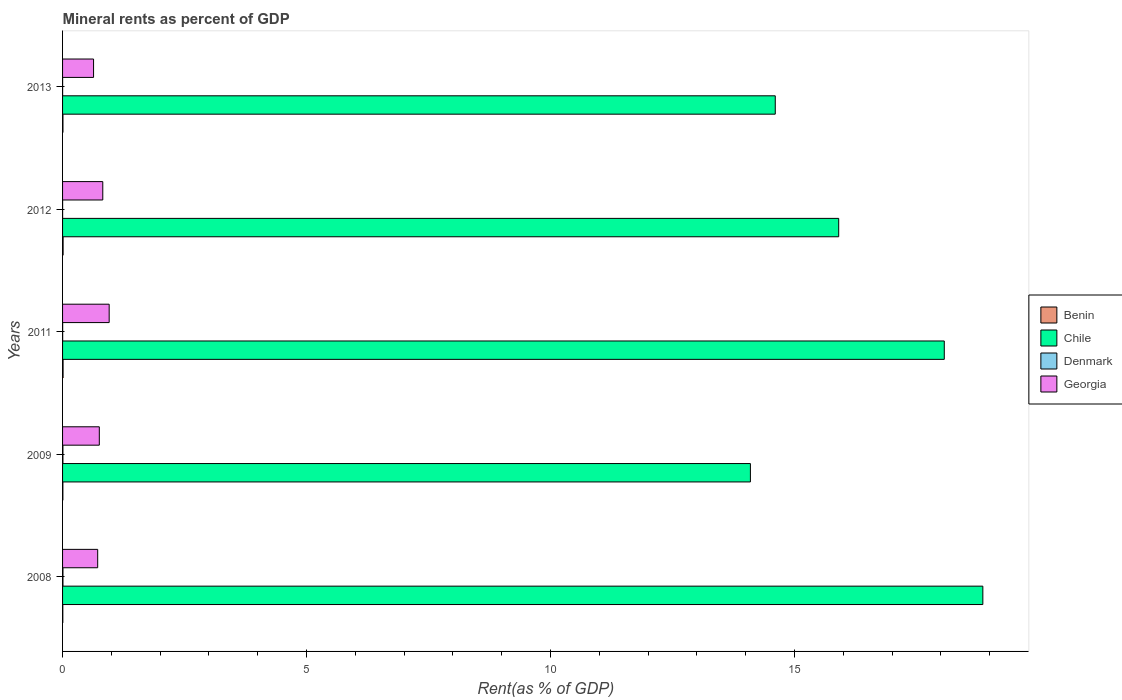How many bars are there on the 5th tick from the top?
Your answer should be compact. 4. How many bars are there on the 5th tick from the bottom?
Provide a short and direct response. 4. What is the label of the 1st group of bars from the top?
Provide a succinct answer. 2013. In how many cases, is the number of bars for a given year not equal to the number of legend labels?
Offer a terse response. 0. What is the mineral rent in Georgia in 2011?
Give a very brief answer. 0.96. Across all years, what is the maximum mineral rent in Chile?
Your answer should be compact. 18.86. Across all years, what is the minimum mineral rent in Georgia?
Give a very brief answer. 0.64. In which year was the mineral rent in Benin minimum?
Provide a short and direct response. 2008. What is the total mineral rent in Georgia in the graph?
Offer a terse response. 3.89. What is the difference between the mineral rent in Georgia in 2011 and that in 2012?
Ensure brevity in your answer.  0.13. What is the difference between the mineral rent in Denmark in 2008 and the mineral rent in Georgia in 2012?
Offer a terse response. -0.82. What is the average mineral rent in Chile per year?
Ensure brevity in your answer.  16.31. In the year 2009, what is the difference between the mineral rent in Georgia and mineral rent in Benin?
Keep it short and to the point. 0.75. In how many years, is the mineral rent in Chile greater than 8 %?
Your response must be concise. 5. What is the ratio of the mineral rent in Benin in 2008 to that in 2013?
Offer a terse response. 0.62. Is the difference between the mineral rent in Georgia in 2011 and 2012 greater than the difference between the mineral rent in Benin in 2011 and 2012?
Ensure brevity in your answer.  Yes. What is the difference between the highest and the second highest mineral rent in Georgia?
Keep it short and to the point. 0.13. What is the difference between the highest and the lowest mineral rent in Georgia?
Your answer should be compact. 0.32. Is the sum of the mineral rent in Benin in 2009 and 2012 greater than the maximum mineral rent in Denmark across all years?
Provide a short and direct response. Yes. What does the 4th bar from the top in 2012 represents?
Provide a succinct answer. Benin. What does the 3rd bar from the bottom in 2011 represents?
Provide a succinct answer. Denmark. Are all the bars in the graph horizontal?
Offer a terse response. Yes. What is the difference between two consecutive major ticks on the X-axis?
Offer a terse response. 5. Are the values on the major ticks of X-axis written in scientific E-notation?
Offer a terse response. No. Does the graph contain any zero values?
Give a very brief answer. No. Does the graph contain grids?
Ensure brevity in your answer.  No. Where does the legend appear in the graph?
Keep it short and to the point. Center right. How are the legend labels stacked?
Offer a terse response. Vertical. What is the title of the graph?
Offer a very short reply. Mineral rents as percent of GDP. What is the label or title of the X-axis?
Give a very brief answer. Rent(as % of GDP). What is the Rent(as % of GDP) of Benin in 2008?
Your answer should be very brief. 0. What is the Rent(as % of GDP) in Chile in 2008?
Make the answer very short. 18.86. What is the Rent(as % of GDP) in Denmark in 2008?
Give a very brief answer. 0.01. What is the Rent(as % of GDP) in Georgia in 2008?
Give a very brief answer. 0.72. What is the Rent(as % of GDP) of Benin in 2009?
Offer a terse response. 0.01. What is the Rent(as % of GDP) of Chile in 2009?
Provide a short and direct response. 14.1. What is the Rent(as % of GDP) in Denmark in 2009?
Give a very brief answer. 0.01. What is the Rent(as % of GDP) in Georgia in 2009?
Keep it short and to the point. 0.75. What is the Rent(as % of GDP) of Benin in 2011?
Your response must be concise. 0.01. What is the Rent(as % of GDP) in Chile in 2011?
Offer a terse response. 18.07. What is the Rent(as % of GDP) of Denmark in 2011?
Provide a short and direct response. 0. What is the Rent(as % of GDP) in Georgia in 2011?
Your response must be concise. 0.96. What is the Rent(as % of GDP) of Benin in 2012?
Ensure brevity in your answer.  0.01. What is the Rent(as % of GDP) in Chile in 2012?
Provide a succinct answer. 15.91. What is the Rent(as % of GDP) of Denmark in 2012?
Give a very brief answer. 0. What is the Rent(as % of GDP) of Georgia in 2012?
Offer a terse response. 0.82. What is the Rent(as % of GDP) in Benin in 2013?
Offer a very short reply. 0.01. What is the Rent(as % of GDP) in Chile in 2013?
Your response must be concise. 14.61. What is the Rent(as % of GDP) of Denmark in 2013?
Provide a short and direct response. 0. What is the Rent(as % of GDP) in Georgia in 2013?
Ensure brevity in your answer.  0.64. Across all years, what is the maximum Rent(as % of GDP) in Benin?
Your answer should be very brief. 0.01. Across all years, what is the maximum Rent(as % of GDP) in Chile?
Make the answer very short. 18.86. Across all years, what is the maximum Rent(as % of GDP) in Denmark?
Offer a very short reply. 0.01. Across all years, what is the maximum Rent(as % of GDP) in Georgia?
Your answer should be compact. 0.96. Across all years, what is the minimum Rent(as % of GDP) in Benin?
Provide a succinct answer. 0. Across all years, what is the minimum Rent(as % of GDP) in Chile?
Provide a short and direct response. 14.1. Across all years, what is the minimum Rent(as % of GDP) of Denmark?
Your answer should be very brief. 0. Across all years, what is the minimum Rent(as % of GDP) of Georgia?
Keep it short and to the point. 0.64. What is the total Rent(as % of GDP) of Benin in the graph?
Offer a terse response. 0.04. What is the total Rent(as % of GDP) of Chile in the graph?
Make the answer very short. 81.54. What is the total Rent(as % of GDP) in Denmark in the graph?
Offer a terse response. 0.02. What is the total Rent(as % of GDP) in Georgia in the graph?
Your response must be concise. 3.89. What is the difference between the Rent(as % of GDP) of Benin in 2008 and that in 2009?
Your response must be concise. -0. What is the difference between the Rent(as % of GDP) of Chile in 2008 and that in 2009?
Offer a terse response. 4.76. What is the difference between the Rent(as % of GDP) of Denmark in 2008 and that in 2009?
Offer a terse response. 0. What is the difference between the Rent(as % of GDP) of Georgia in 2008 and that in 2009?
Your answer should be very brief. -0.03. What is the difference between the Rent(as % of GDP) in Benin in 2008 and that in 2011?
Keep it short and to the point. -0.01. What is the difference between the Rent(as % of GDP) in Chile in 2008 and that in 2011?
Keep it short and to the point. 0.79. What is the difference between the Rent(as % of GDP) of Denmark in 2008 and that in 2011?
Provide a short and direct response. 0.01. What is the difference between the Rent(as % of GDP) of Georgia in 2008 and that in 2011?
Ensure brevity in your answer.  -0.24. What is the difference between the Rent(as % of GDP) of Benin in 2008 and that in 2012?
Ensure brevity in your answer.  -0.01. What is the difference between the Rent(as % of GDP) of Chile in 2008 and that in 2012?
Your answer should be compact. 2.95. What is the difference between the Rent(as % of GDP) in Denmark in 2008 and that in 2012?
Make the answer very short. 0.01. What is the difference between the Rent(as % of GDP) in Georgia in 2008 and that in 2012?
Ensure brevity in your answer.  -0.1. What is the difference between the Rent(as % of GDP) in Benin in 2008 and that in 2013?
Make the answer very short. -0. What is the difference between the Rent(as % of GDP) in Chile in 2008 and that in 2013?
Provide a short and direct response. 4.25. What is the difference between the Rent(as % of GDP) of Denmark in 2008 and that in 2013?
Make the answer very short. 0.01. What is the difference between the Rent(as % of GDP) in Georgia in 2008 and that in 2013?
Make the answer very short. 0.08. What is the difference between the Rent(as % of GDP) in Benin in 2009 and that in 2011?
Keep it short and to the point. -0. What is the difference between the Rent(as % of GDP) in Chile in 2009 and that in 2011?
Give a very brief answer. -3.97. What is the difference between the Rent(as % of GDP) in Denmark in 2009 and that in 2011?
Ensure brevity in your answer.  0.01. What is the difference between the Rent(as % of GDP) of Georgia in 2009 and that in 2011?
Make the answer very short. -0.2. What is the difference between the Rent(as % of GDP) of Benin in 2009 and that in 2012?
Give a very brief answer. -0. What is the difference between the Rent(as % of GDP) of Chile in 2009 and that in 2012?
Give a very brief answer. -1.81. What is the difference between the Rent(as % of GDP) of Denmark in 2009 and that in 2012?
Ensure brevity in your answer.  0.01. What is the difference between the Rent(as % of GDP) of Georgia in 2009 and that in 2012?
Provide a short and direct response. -0.07. What is the difference between the Rent(as % of GDP) in Benin in 2009 and that in 2013?
Offer a very short reply. -0. What is the difference between the Rent(as % of GDP) in Chile in 2009 and that in 2013?
Your answer should be very brief. -0.51. What is the difference between the Rent(as % of GDP) of Denmark in 2009 and that in 2013?
Provide a short and direct response. 0.01. What is the difference between the Rent(as % of GDP) of Georgia in 2009 and that in 2013?
Your response must be concise. 0.12. What is the difference between the Rent(as % of GDP) in Benin in 2011 and that in 2012?
Give a very brief answer. -0. What is the difference between the Rent(as % of GDP) in Chile in 2011 and that in 2012?
Your answer should be compact. 2.16. What is the difference between the Rent(as % of GDP) in Denmark in 2011 and that in 2012?
Make the answer very short. 0. What is the difference between the Rent(as % of GDP) of Georgia in 2011 and that in 2012?
Keep it short and to the point. 0.13. What is the difference between the Rent(as % of GDP) in Benin in 2011 and that in 2013?
Keep it short and to the point. 0. What is the difference between the Rent(as % of GDP) in Chile in 2011 and that in 2013?
Give a very brief answer. 3.46. What is the difference between the Rent(as % of GDP) in Denmark in 2011 and that in 2013?
Offer a very short reply. 0. What is the difference between the Rent(as % of GDP) in Georgia in 2011 and that in 2013?
Your response must be concise. 0.32. What is the difference between the Rent(as % of GDP) in Benin in 2012 and that in 2013?
Offer a very short reply. 0. What is the difference between the Rent(as % of GDP) of Denmark in 2012 and that in 2013?
Your answer should be compact. 0. What is the difference between the Rent(as % of GDP) in Georgia in 2012 and that in 2013?
Provide a short and direct response. 0.19. What is the difference between the Rent(as % of GDP) of Benin in 2008 and the Rent(as % of GDP) of Chile in 2009?
Keep it short and to the point. -14.09. What is the difference between the Rent(as % of GDP) in Benin in 2008 and the Rent(as % of GDP) in Denmark in 2009?
Offer a very short reply. -0. What is the difference between the Rent(as % of GDP) in Benin in 2008 and the Rent(as % of GDP) in Georgia in 2009?
Make the answer very short. -0.75. What is the difference between the Rent(as % of GDP) in Chile in 2008 and the Rent(as % of GDP) in Denmark in 2009?
Give a very brief answer. 18.85. What is the difference between the Rent(as % of GDP) in Chile in 2008 and the Rent(as % of GDP) in Georgia in 2009?
Your answer should be compact. 18.11. What is the difference between the Rent(as % of GDP) in Denmark in 2008 and the Rent(as % of GDP) in Georgia in 2009?
Your answer should be very brief. -0.75. What is the difference between the Rent(as % of GDP) of Benin in 2008 and the Rent(as % of GDP) of Chile in 2011?
Offer a very short reply. -18.06. What is the difference between the Rent(as % of GDP) in Benin in 2008 and the Rent(as % of GDP) in Denmark in 2011?
Offer a terse response. 0. What is the difference between the Rent(as % of GDP) of Benin in 2008 and the Rent(as % of GDP) of Georgia in 2011?
Provide a short and direct response. -0.95. What is the difference between the Rent(as % of GDP) of Chile in 2008 and the Rent(as % of GDP) of Denmark in 2011?
Keep it short and to the point. 18.86. What is the difference between the Rent(as % of GDP) of Chile in 2008 and the Rent(as % of GDP) of Georgia in 2011?
Make the answer very short. 17.9. What is the difference between the Rent(as % of GDP) of Denmark in 2008 and the Rent(as % of GDP) of Georgia in 2011?
Keep it short and to the point. -0.95. What is the difference between the Rent(as % of GDP) of Benin in 2008 and the Rent(as % of GDP) of Chile in 2012?
Provide a short and direct response. -15.9. What is the difference between the Rent(as % of GDP) of Benin in 2008 and the Rent(as % of GDP) of Denmark in 2012?
Your answer should be compact. 0. What is the difference between the Rent(as % of GDP) in Benin in 2008 and the Rent(as % of GDP) in Georgia in 2012?
Give a very brief answer. -0.82. What is the difference between the Rent(as % of GDP) of Chile in 2008 and the Rent(as % of GDP) of Denmark in 2012?
Provide a short and direct response. 18.86. What is the difference between the Rent(as % of GDP) in Chile in 2008 and the Rent(as % of GDP) in Georgia in 2012?
Your response must be concise. 18.04. What is the difference between the Rent(as % of GDP) of Denmark in 2008 and the Rent(as % of GDP) of Georgia in 2012?
Provide a short and direct response. -0.82. What is the difference between the Rent(as % of GDP) in Benin in 2008 and the Rent(as % of GDP) in Chile in 2013?
Your answer should be very brief. -14.6. What is the difference between the Rent(as % of GDP) of Benin in 2008 and the Rent(as % of GDP) of Denmark in 2013?
Your response must be concise. 0. What is the difference between the Rent(as % of GDP) of Benin in 2008 and the Rent(as % of GDP) of Georgia in 2013?
Provide a short and direct response. -0.63. What is the difference between the Rent(as % of GDP) in Chile in 2008 and the Rent(as % of GDP) in Denmark in 2013?
Ensure brevity in your answer.  18.86. What is the difference between the Rent(as % of GDP) of Chile in 2008 and the Rent(as % of GDP) of Georgia in 2013?
Your answer should be very brief. 18.22. What is the difference between the Rent(as % of GDP) in Denmark in 2008 and the Rent(as % of GDP) in Georgia in 2013?
Provide a short and direct response. -0.63. What is the difference between the Rent(as % of GDP) in Benin in 2009 and the Rent(as % of GDP) in Chile in 2011?
Provide a succinct answer. -18.06. What is the difference between the Rent(as % of GDP) of Benin in 2009 and the Rent(as % of GDP) of Denmark in 2011?
Make the answer very short. 0. What is the difference between the Rent(as % of GDP) in Benin in 2009 and the Rent(as % of GDP) in Georgia in 2011?
Keep it short and to the point. -0.95. What is the difference between the Rent(as % of GDP) in Chile in 2009 and the Rent(as % of GDP) in Denmark in 2011?
Your answer should be very brief. 14.09. What is the difference between the Rent(as % of GDP) in Chile in 2009 and the Rent(as % of GDP) in Georgia in 2011?
Offer a very short reply. 13.14. What is the difference between the Rent(as % of GDP) of Denmark in 2009 and the Rent(as % of GDP) of Georgia in 2011?
Make the answer very short. -0.95. What is the difference between the Rent(as % of GDP) of Benin in 2009 and the Rent(as % of GDP) of Chile in 2012?
Provide a short and direct response. -15.9. What is the difference between the Rent(as % of GDP) in Benin in 2009 and the Rent(as % of GDP) in Denmark in 2012?
Keep it short and to the point. 0.01. What is the difference between the Rent(as % of GDP) in Benin in 2009 and the Rent(as % of GDP) in Georgia in 2012?
Make the answer very short. -0.82. What is the difference between the Rent(as % of GDP) of Chile in 2009 and the Rent(as % of GDP) of Denmark in 2012?
Your answer should be compact. 14.1. What is the difference between the Rent(as % of GDP) of Chile in 2009 and the Rent(as % of GDP) of Georgia in 2012?
Make the answer very short. 13.27. What is the difference between the Rent(as % of GDP) of Denmark in 2009 and the Rent(as % of GDP) of Georgia in 2012?
Your answer should be very brief. -0.82. What is the difference between the Rent(as % of GDP) of Benin in 2009 and the Rent(as % of GDP) of Chile in 2013?
Offer a terse response. -14.6. What is the difference between the Rent(as % of GDP) in Benin in 2009 and the Rent(as % of GDP) in Denmark in 2013?
Give a very brief answer. 0.01. What is the difference between the Rent(as % of GDP) of Benin in 2009 and the Rent(as % of GDP) of Georgia in 2013?
Offer a very short reply. -0.63. What is the difference between the Rent(as % of GDP) in Chile in 2009 and the Rent(as % of GDP) in Denmark in 2013?
Provide a succinct answer. 14.1. What is the difference between the Rent(as % of GDP) in Chile in 2009 and the Rent(as % of GDP) in Georgia in 2013?
Offer a very short reply. 13.46. What is the difference between the Rent(as % of GDP) in Denmark in 2009 and the Rent(as % of GDP) in Georgia in 2013?
Make the answer very short. -0.63. What is the difference between the Rent(as % of GDP) in Benin in 2011 and the Rent(as % of GDP) in Chile in 2012?
Provide a succinct answer. -15.9. What is the difference between the Rent(as % of GDP) of Benin in 2011 and the Rent(as % of GDP) of Denmark in 2012?
Offer a very short reply. 0.01. What is the difference between the Rent(as % of GDP) of Benin in 2011 and the Rent(as % of GDP) of Georgia in 2012?
Ensure brevity in your answer.  -0.81. What is the difference between the Rent(as % of GDP) of Chile in 2011 and the Rent(as % of GDP) of Denmark in 2012?
Offer a terse response. 18.07. What is the difference between the Rent(as % of GDP) of Chile in 2011 and the Rent(as % of GDP) of Georgia in 2012?
Your response must be concise. 17.25. What is the difference between the Rent(as % of GDP) of Denmark in 2011 and the Rent(as % of GDP) of Georgia in 2012?
Give a very brief answer. -0.82. What is the difference between the Rent(as % of GDP) in Benin in 2011 and the Rent(as % of GDP) in Chile in 2013?
Provide a short and direct response. -14.6. What is the difference between the Rent(as % of GDP) in Benin in 2011 and the Rent(as % of GDP) in Denmark in 2013?
Give a very brief answer. 0.01. What is the difference between the Rent(as % of GDP) of Benin in 2011 and the Rent(as % of GDP) of Georgia in 2013?
Your response must be concise. -0.62. What is the difference between the Rent(as % of GDP) in Chile in 2011 and the Rent(as % of GDP) in Denmark in 2013?
Keep it short and to the point. 18.07. What is the difference between the Rent(as % of GDP) in Chile in 2011 and the Rent(as % of GDP) in Georgia in 2013?
Offer a terse response. 17.43. What is the difference between the Rent(as % of GDP) of Denmark in 2011 and the Rent(as % of GDP) of Georgia in 2013?
Provide a succinct answer. -0.63. What is the difference between the Rent(as % of GDP) in Benin in 2012 and the Rent(as % of GDP) in Chile in 2013?
Offer a very short reply. -14.59. What is the difference between the Rent(as % of GDP) of Benin in 2012 and the Rent(as % of GDP) of Denmark in 2013?
Provide a succinct answer. 0.01. What is the difference between the Rent(as % of GDP) of Benin in 2012 and the Rent(as % of GDP) of Georgia in 2013?
Your answer should be compact. -0.62. What is the difference between the Rent(as % of GDP) in Chile in 2012 and the Rent(as % of GDP) in Denmark in 2013?
Your answer should be very brief. 15.9. What is the difference between the Rent(as % of GDP) of Chile in 2012 and the Rent(as % of GDP) of Georgia in 2013?
Give a very brief answer. 15.27. What is the difference between the Rent(as % of GDP) in Denmark in 2012 and the Rent(as % of GDP) in Georgia in 2013?
Your answer should be compact. -0.63. What is the average Rent(as % of GDP) of Benin per year?
Your answer should be very brief. 0.01. What is the average Rent(as % of GDP) of Chile per year?
Give a very brief answer. 16.31. What is the average Rent(as % of GDP) of Denmark per year?
Provide a succinct answer. 0. What is the average Rent(as % of GDP) in Georgia per year?
Your answer should be very brief. 0.78. In the year 2008, what is the difference between the Rent(as % of GDP) in Benin and Rent(as % of GDP) in Chile?
Provide a short and direct response. -18.85. In the year 2008, what is the difference between the Rent(as % of GDP) of Benin and Rent(as % of GDP) of Denmark?
Provide a short and direct response. -0. In the year 2008, what is the difference between the Rent(as % of GDP) of Benin and Rent(as % of GDP) of Georgia?
Your answer should be very brief. -0.71. In the year 2008, what is the difference between the Rent(as % of GDP) in Chile and Rent(as % of GDP) in Denmark?
Provide a succinct answer. 18.85. In the year 2008, what is the difference between the Rent(as % of GDP) of Chile and Rent(as % of GDP) of Georgia?
Offer a terse response. 18.14. In the year 2008, what is the difference between the Rent(as % of GDP) in Denmark and Rent(as % of GDP) in Georgia?
Provide a succinct answer. -0.71. In the year 2009, what is the difference between the Rent(as % of GDP) in Benin and Rent(as % of GDP) in Chile?
Offer a very short reply. -14.09. In the year 2009, what is the difference between the Rent(as % of GDP) of Benin and Rent(as % of GDP) of Denmark?
Make the answer very short. -0. In the year 2009, what is the difference between the Rent(as % of GDP) in Benin and Rent(as % of GDP) in Georgia?
Provide a succinct answer. -0.75. In the year 2009, what is the difference between the Rent(as % of GDP) in Chile and Rent(as % of GDP) in Denmark?
Your response must be concise. 14.09. In the year 2009, what is the difference between the Rent(as % of GDP) of Chile and Rent(as % of GDP) of Georgia?
Ensure brevity in your answer.  13.34. In the year 2009, what is the difference between the Rent(as % of GDP) in Denmark and Rent(as % of GDP) in Georgia?
Offer a very short reply. -0.75. In the year 2011, what is the difference between the Rent(as % of GDP) of Benin and Rent(as % of GDP) of Chile?
Keep it short and to the point. -18.06. In the year 2011, what is the difference between the Rent(as % of GDP) of Benin and Rent(as % of GDP) of Denmark?
Provide a succinct answer. 0.01. In the year 2011, what is the difference between the Rent(as % of GDP) in Benin and Rent(as % of GDP) in Georgia?
Provide a short and direct response. -0.94. In the year 2011, what is the difference between the Rent(as % of GDP) of Chile and Rent(as % of GDP) of Denmark?
Offer a terse response. 18.07. In the year 2011, what is the difference between the Rent(as % of GDP) of Chile and Rent(as % of GDP) of Georgia?
Provide a short and direct response. 17.11. In the year 2011, what is the difference between the Rent(as % of GDP) in Denmark and Rent(as % of GDP) in Georgia?
Provide a succinct answer. -0.95. In the year 2012, what is the difference between the Rent(as % of GDP) in Benin and Rent(as % of GDP) in Chile?
Your answer should be very brief. -15.89. In the year 2012, what is the difference between the Rent(as % of GDP) in Benin and Rent(as % of GDP) in Denmark?
Make the answer very short. 0.01. In the year 2012, what is the difference between the Rent(as % of GDP) in Benin and Rent(as % of GDP) in Georgia?
Your answer should be compact. -0.81. In the year 2012, what is the difference between the Rent(as % of GDP) in Chile and Rent(as % of GDP) in Denmark?
Make the answer very short. 15.9. In the year 2012, what is the difference between the Rent(as % of GDP) in Chile and Rent(as % of GDP) in Georgia?
Offer a very short reply. 15.08. In the year 2012, what is the difference between the Rent(as % of GDP) of Denmark and Rent(as % of GDP) of Georgia?
Ensure brevity in your answer.  -0.82. In the year 2013, what is the difference between the Rent(as % of GDP) of Benin and Rent(as % of GDP) of Chile?
Offer a terse response. -14.6. In the year 2013, what is the difference between the Rent(as % of GDP) of Benin and Rent(as % of GDP) of Denmark?
Your answer should be compact. 0.01. In the year 2013, what is the difference between the Rent(as % of GDP) in Benin and Rent(as % of GDP) in Georgia?
Your response must be concise. -0.63. In the year 2013, what is the difference between the Rent(as % of GDP) in Chile and Rent(as % of GDP) in Denmark?
Give a very brief answer. 14.61. In the year 2013, what is the difference between the Rent(as % of GDP) of Chile and Rent(as % of GDP) of Georgia?
Your answer should be very brief. 13.97. In the year 2013, what is the difference between the Rent(as % of GDP) of Denmark and Rent(as % of GDP) of Georgia?
Give a very brief answer. -0.63. What is the ratio of the Rent(as % of GDP) in Benin in 2008 to that in 2009?
Ensure brevity in your answer.  0.8. What is the ratio of the Rent(as % of GDP) of Chile in 2008 to that in 2009?
Your response must be concise. 1.34. What is the ratio of the Rent(as % of GDP) in Georgia in 2008 to that in 2009?
Ensure brevity in your answer.  0.96. What is the ratio of the Rent(as % of GDP) of Benin in 2008 to that in 2011?
Offer a very short reply. 0.48. What is the ratio of the Rent(as % of GDP) of Chile in 2008 to that in 2011?
Give a very brief answer. 1.04. What is the ratio of the Rent(as % of GDP) in Denmark in 2008 to that in 2011?
Your answer should be very brief. 4.56. What is the ratio of the Rent(as % of GDP) in Georgia in 2008 to that in 2011?
Your answer should be very brief. 0.75. What is the ratio of the Rent(as % of GDP) of Benin in 2008 to that in 2012?
Provide a succinct answer. 0.45. What is the ratio of the Rent(as % of GDP) of Chile in 2008 to that in 2012?
Offer a terse response. 1.19. What is the ratio of the Rent(as % of GDP) of Denmark in 2008 to that in 2012?
Keep it short and to the point. 7.91. What is the ratio of the Rent(as % of GDP) in Georgia in 2008 to that in 2012?
Offer a terse response. 0.87. What is the ratio of the Rent(as % of GDP) in Benin in 2008 to that in 2013?
Ensure brevity in your answer.  0.62. What is the ratio of the Rent(as % of GDP) of Chile in 2008 to that in 2013?
Ensure brevity in your answer.  1.29. What is the ratio of the Rent(as % of GDP) of Denmark in 2008 to that in 2013?
Your response must be concise. 10.24. What is the ratio of the Rent(as % of GDP) in Georgia in 2008 to that in 2013?
Make the answer very short. 1.13. What is the ratio of the Rent(as % of GDP) of Benin in 2009 to that in 2011?
Ensure brevity in your answer.  0.59. What is the ratio of the Rent(as % of GDP) in Chile in 2009 to that in 2011?
Give a very brief answer. 0.78. What is the ratio of the Rent(as % of GDP) of Denmark in 2009 to that in 2011?
Your answer should be very brief. 4.18. What is the ratio of the Rent(as % of GDP) of Georgia in 2009 to that in 2011?
Your response must be concise. 0.79. What is the ratio of the Rent(as % of GDP) of Benin in 2009 to that in 2012?
Your response must be concise. 0.56. What is the ratio of the Rent(as % of GDP) in Chile in 2009 to that in 2012?
Offer a very short reply. 0.89. What is the ratio of the Rent(as % of GDP) of Denmark in 2009 to that in 2012?
Your response must be concise. 7.25. What is the ratio of the Rent(as % of GDP) of Georgia in 2009 to that in 2012?
Offer a very short reply. 0.91. What is the ratio of the Rent(as % of GDP) in Benin in 2009 to that in 2013?
Make the answer very short. 0.77. What is the ratio of the Rent(as % of GDP) of Chile in 2009 to that in 2013?
Ensure brevity in your answer.  0.97. What is the ratio of the Rent(as % of GDP) in Denmark in 2009 to that in 2013?
Provide a short and direct response. 9.38. What is the ratio of the Rent(as % of GDP) of Georgia in 2009 to that in 2013?
Keep it short and to the point. 1.19. What is the ratio of the Rent(as % of GDP) in Benin in 2011 to that in 2012?
Keep it short and to the point. 0.95. What is the ratio of the Rent(as % of GDP) in Chile in 2011 to that in 2012?
Your response must be concise. 1.14. What is the ratio of the Rent(as % of GDP) of Denmark in 2011 to that in 2012?
Ensure brevity in your answer.  1.73. What is the ratio of the Rent(as % of GDP) in Georgia in 2011 to that in 2012?
Give a very brief answer. 1.16. What is the ratio of the Rent(as % of GDP) in Benin in 2011 to that in 2013?
Provide a short and direct response. 1.3. What is the ratio of the Rent(as % of GDP) of Chile in 2011 to that in 2013?
Make the answer very short. 1.24. What is the ratio of the Rent(as % of GDP) in Denmark in 2011 to that in 2013?
Make the answer very short. 2.25. What is the ratio of the Rent(as % of GDP) in Georgia in 2011 to that in 2013?
Offer a terse response. 1.5. What is the ratio of the Rent(as % of GDP) in Benin in 2012 to that in 2013?
Provide a succinct answer. 1.37. What is the ratio of the Rent(as % of GDP) of Chile in 2012 to that in 2013?
Offer a very short reply. 1.09. What is the ratio of the Rent(as % of GDP) of Denmark in 2012 to that in 2013?
Keep it short and to the point. 1.29. What is the ratio of the Rent(as % of GDP) in Georgia in 2012 to that in 2013?
Make the answer very short. 1.3. What is the difference between the highest and the second highest Rent(as % of GDP) of Chile?
Make the answer very short. 0.79. What is the difference between the highest and the second highest Rent(as % of GDP) in Denmark?
Your response must be concise. 0. What is the difference between the highest and the second highest Rent(as % of GDP) in Georgia?
Provide a succinct answer. 0.13. What is the difference between the highest and the lowest Rent(as % of GDP) of Benin?
Your response must be concise. 0.01. What is the difference between the highest and the lowest Rent(as % of GDP) of Chile?
Your answer should be compact. 4.76. What is the difference between the highest and the lowest Rent(as % of GDP) of Denmark?
Ensure brevity in your answer.  0.01. What is the difference between the highest and the lowest Rent(as % of GDP) of Georgia?
Your answer should be very brief. 0.32. 